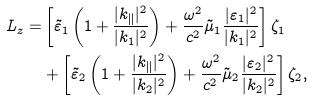<formula> <loc_0><loc_0><loc_500><loc_500>L _ { z } = & \left [ \tilde { \varepsilon } _ { 1 } \left ( 1 + \frac { | k _ { \| } | ^ { 2 } } { | k _ { 1 } | ^ { 2 } } \right ) + \frac { \omega ^ { 2 } } { c ^ { 2 } } \tilde { \mu } _ { 1 } \frac { | \varepsilon _ { 1 } | ^ { 2 } } { | k _ { 1 } | ^ { 2 } } \right ] \zeta _ { 1 } \\ & + \left [ \tilde { \varepsilon } _ { 2 } \left ( 1 + \frac { | k _ { \| } | ^ { 2 } } { | k _ { 2 } | ^ { 2 } } \right ) + \frac { \omega ^ { 2 } } { c ^ { 2 } } \tilde { \mu } _ { 2 } \frac { | \varepsilon _ { 2 } | ^ { 2 } } { | k _ { 2 } | ^ { 2 } } \right ] \zeta _ { 2 } ,</formula> 